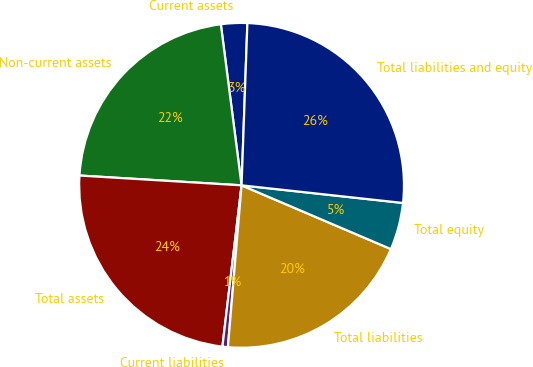Convert chart. <chart><loc_0><loc_0><loc_500><loc_500><pie_chart><fcel>Current assets<fcel>Non-current assets<fcel>Total assets<fcel>Current liabilities<fcel>Total liabilities<fcel>Total equity<fcel>Total liabilities and equity<nl><fcel>2.61%<fcel>22.0%<fcel>24.08%<fcel>0.54%<fcel>19.92%<fcel>4.69%<fcel>26.16%<nl></chart> 